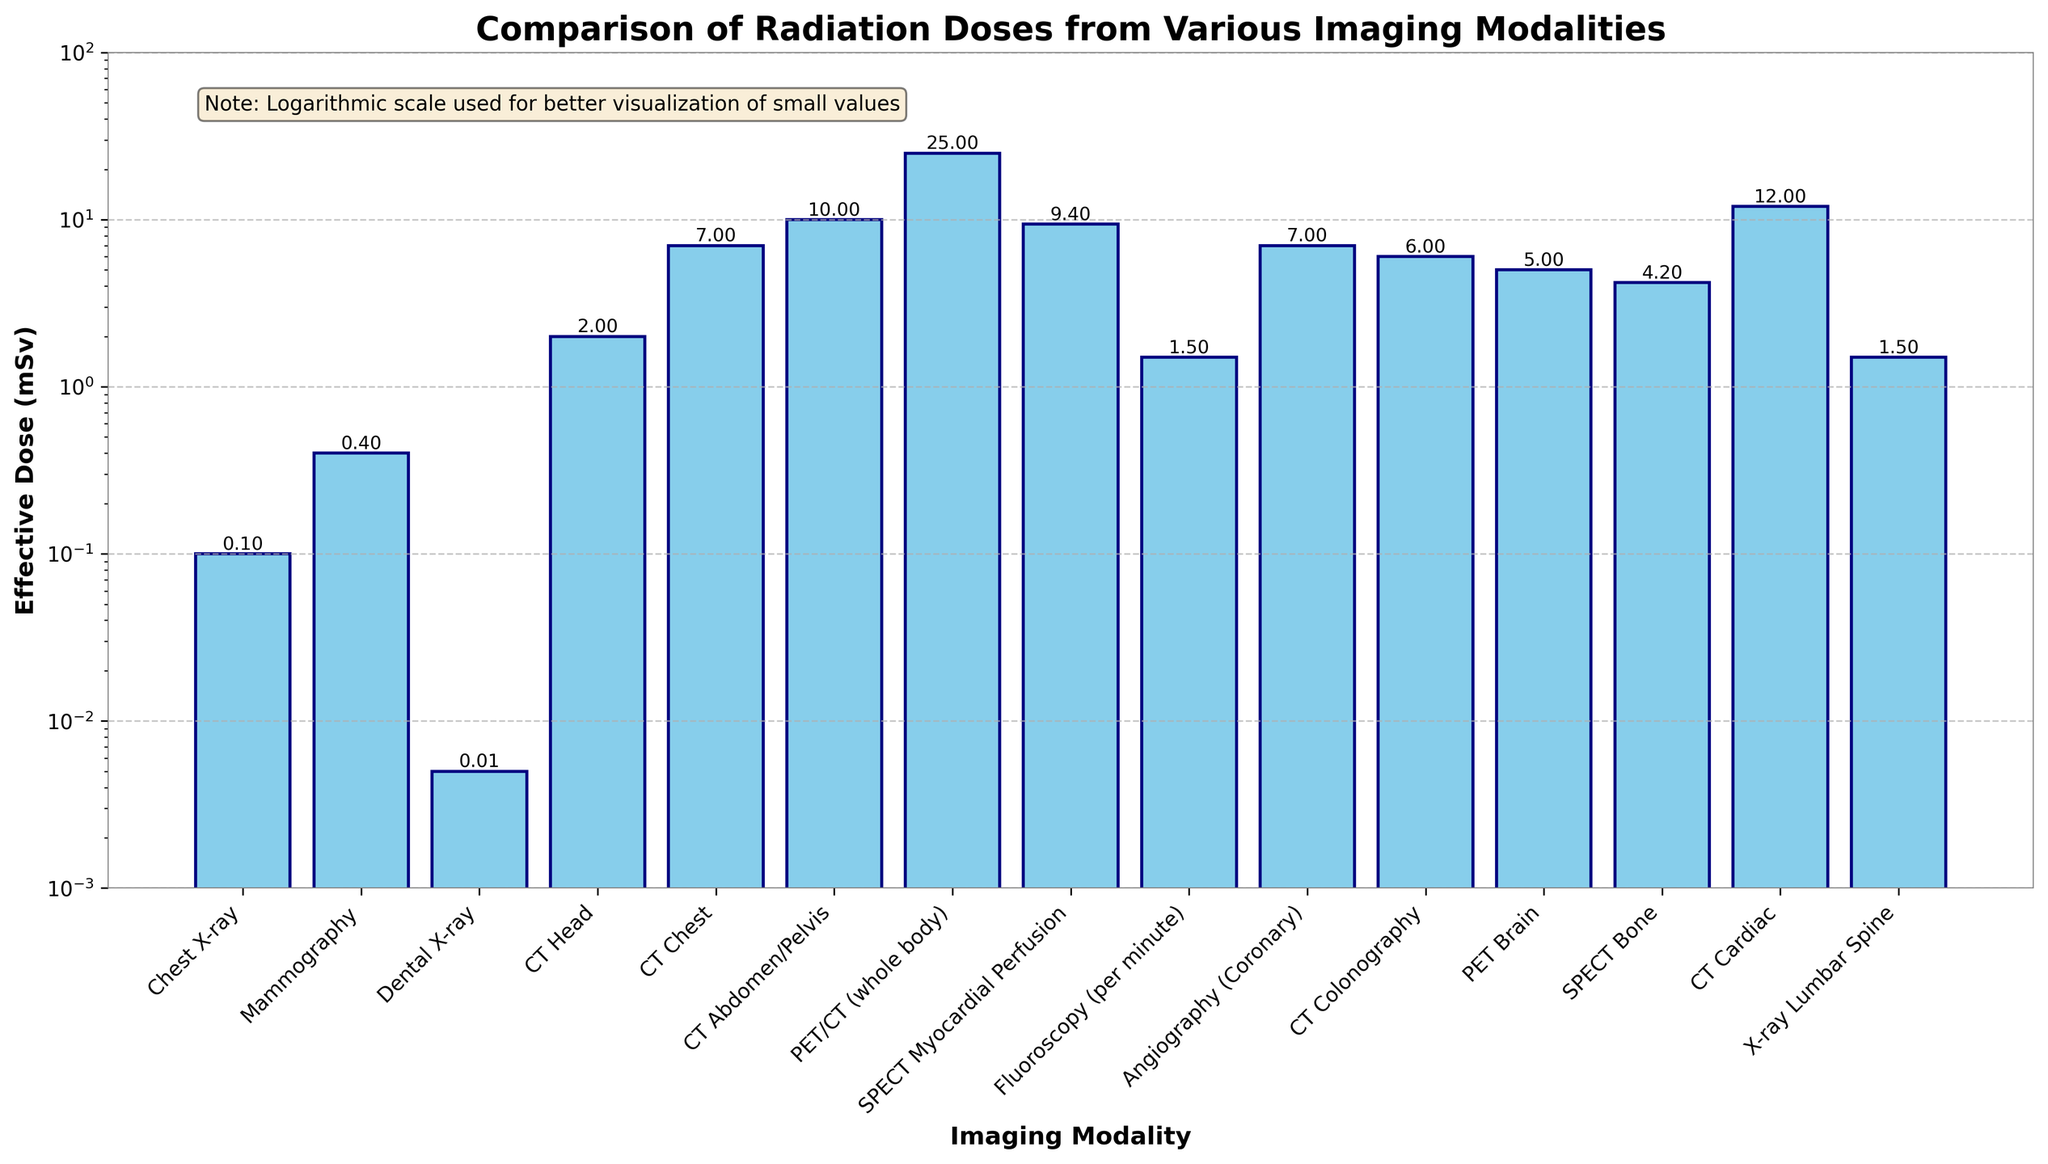What is the imaging modality with the highest radiation dose? The bar representing the PET/CT (whole body) is the tallest among all the bars in the plot, indicating that it has the highest radiation dose.
Answer: PET/CT (whole body) Which has the higher radiation dose: CT Abdomen/Pelvis or CT Colonography? By comparing the heights of the bars, the CT Abdomen/Pelvis bar is taller than the CT Colonography bar, indicating a higher radiation dose.
Answer: CT Abdomen/Pelvis What's the difference in effective dose between a CT Cardiac and a Chest X-ray? The effective dose for a CT Cardiac is 12 mSv and for a Chest X-ray is 0.1 mSv. Subtracting these values gives 11.9 mSv.
Answer: 11.9 mSv Which imaging modality has a radiation dose closest to 1 mSv? The X-ray Lumbar Spine has a dose of 1.5 mSv and is the closest value to 1 mSv among the displayed bars.
Answer: X-ray Lumbar Spine Rank the CT-related imaging modalities from lowest to highest radiation dose. The CT-related modalities are CT Head (2 mSv), CT Colonography (6 mSv), CT Chest (7 mSv), CT Abdomen/Pelvis (10 mSv), and CT Cardiac (12 mSv). Ordering these from lowest to highest doses, we get: CT Head, CT Colonography, CT Chest, CT Abdomen/Pelvis, and CT Cardiac.
Answer: CT Head, CT Colonography, CT Chest, CT Abdomen/Pelvis, CT Cardiac What is the average effective dose for PET Brain, SPECT Bone, and CT Cardiac? The effective doses are PET Brain (5 mSv), SPECT Bone (4.2 mSv), and CT Cardiac (12 mSv). The sum of these values is 21.2 mSv, and the average is 21.2/3 = 7.07 mSv.
Answer: 7.07 mSv How does the effective dose of dental X-ray compare to that of fluoroscopy (per minute)? The effective dose of a dental X-ray is 0.005 mSv, while for fluoroscopy (per minute) it is 1.5 mSv. The bar for fluoroscopy is significantly taller than that for the dental X-ray.
Answer: Fluoroscopy (per minute) is much higher What imaging modality has a dose that is roughly one-tenth of the SPECT Myocardial Perfusion? The dose for SPECT Myocardial Perfusion is 9.4 mSv. One-tenth of this value is 0.94 mSv, which is closest to the dose of a Chest X-ray (0.1 mSv).
Answer: Chest X-ray How many imaging modalities have an effective dose higher than 5 mSv? By identifying the bars taller than the 5 mSv mark, we can count them: CT Abdomen/Pelvis, CT Chest, CT Cardiac, PET/CT (whole body), and SPECT Myocardial Perfusion. This totals to 5 modalities.
Answer: 5 Does mammography or PET Brain have a higher radiation dose? The bar for PET Brain (5 mSv) is taller than the bar for Mammography (0.4 mSv), indicating a higher radiation dose for PET Brain.
Answer: PET Brain 